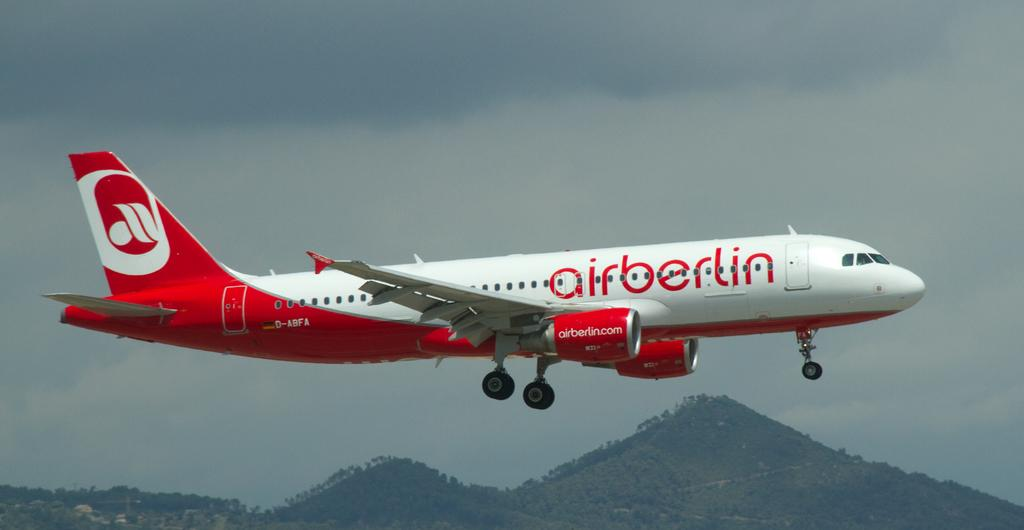What is the main subject of the image? The main subject of the image is an aeroplane. What is the aeroplane doing in the image? The aeroplane is flying in the sky. What can be seen written on the aeroplane? "Air Berlin" is written on the aeroplane. What type of landscape is visible in the background of the image? Hills are visible in the background of the image. How would you describe the weather in the image? The sky is cloudy in the image. What type of pan is being used to control the army in the image? There is no pan or army present in the image; it features an aeroplane flying in the sky. 